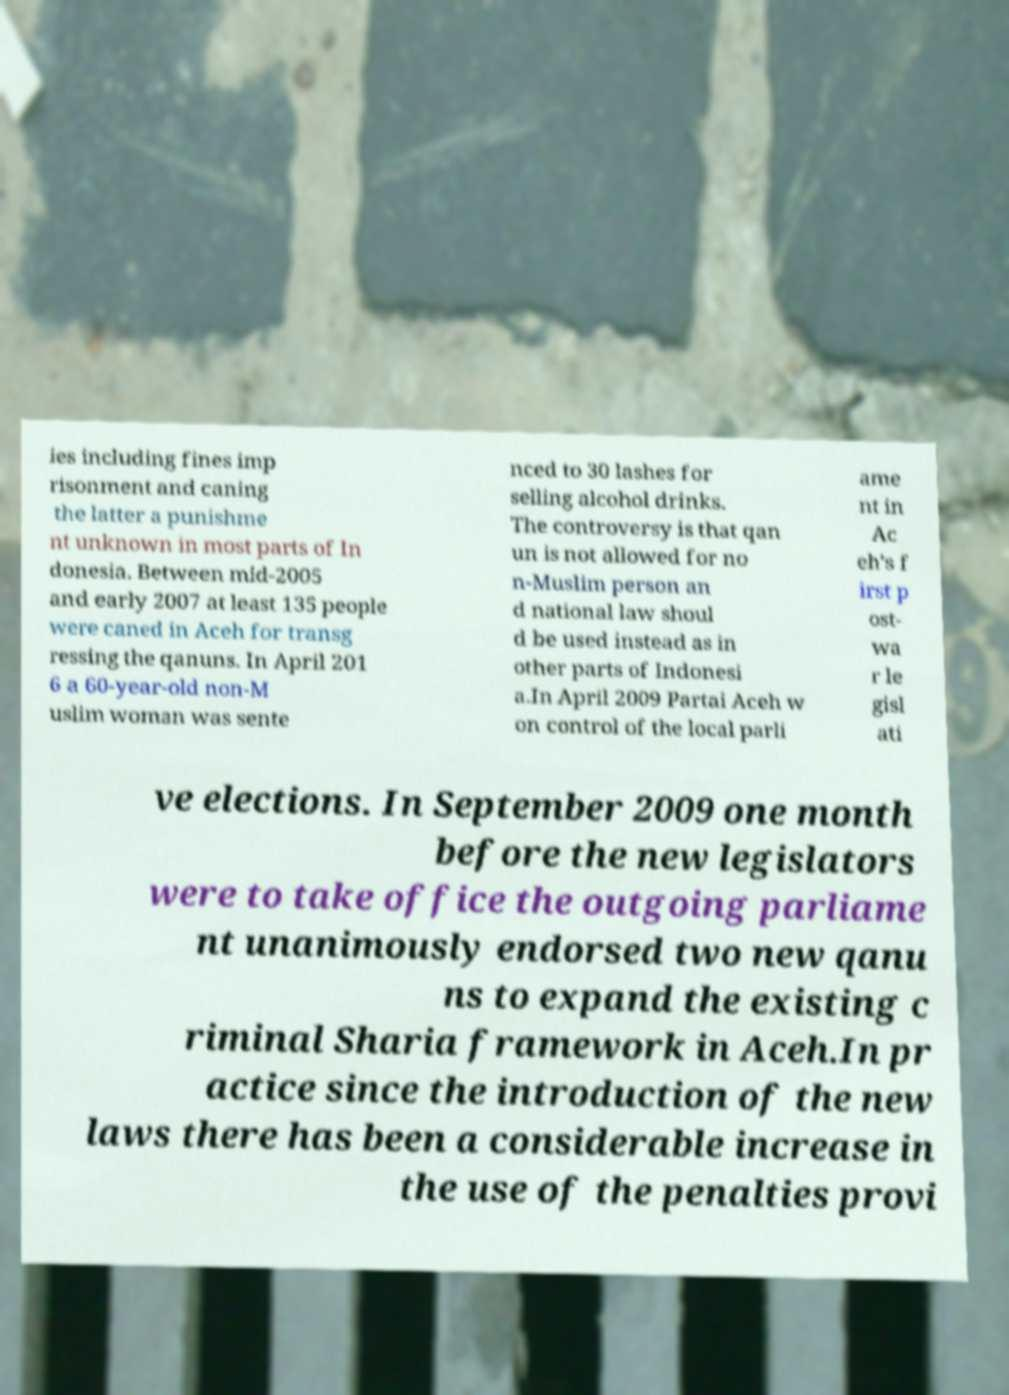Could you assist in decoding the text presented in this image and type it out clearly? ies including fines imp risonment and caning the latter a punishme nt unknown in most parts of In donesia. Between mid-2005 and early 2007 at least 135 people were caned in Aceh for transg ressing the qanuns. In April 201 6 a 60-year-old non-M uslim woman was sente nced to 30 lashes for selling alcohol drinks. The controversy is that qan un is not allowed for no n-Muslim person an d national law shoul d be used instead as in other parts of Indonesi a.In April 2009 Partai Aceh w on control of the local parli ame nt in Ac eh's f irst p ost- wa r le gisl ati ve elections. In September 2009 one month before the new legislators were to take office the outgoing parliame nt unanimously endorsed two new qanu ns to expand the existing c riminal Sharia framework in Aceh.In pr actice since the introduction of the new laws there has been a considerable increase in the use of the penalties provi 